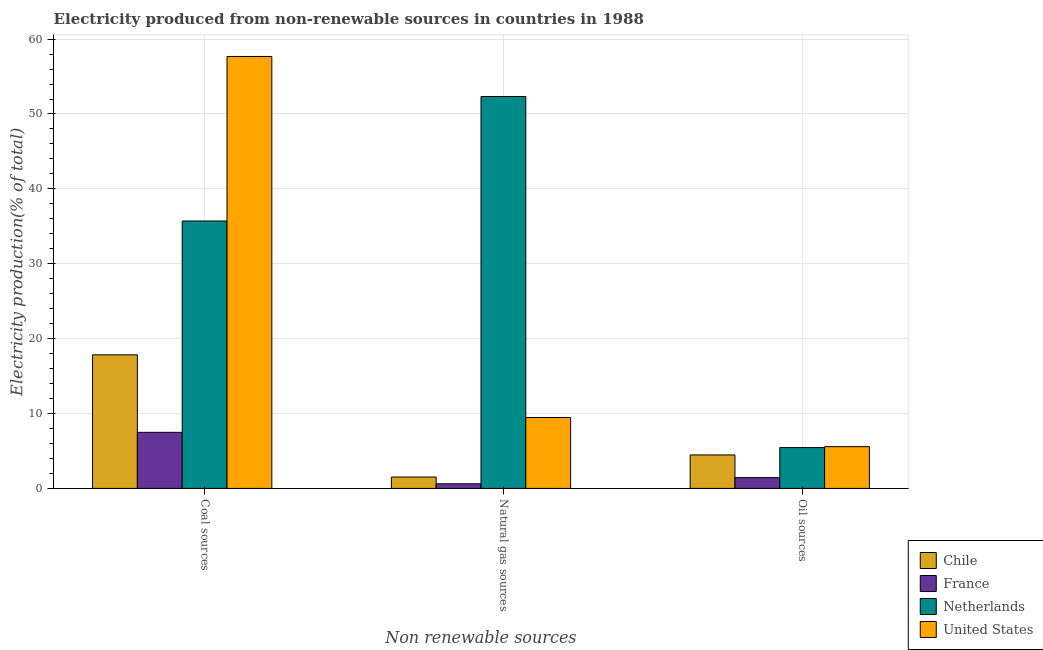How many groups of bars are there?
Provide a short and direct response. 3. Are the number of bars per tick equal to the number of legend labels?
Offer a very short reply. Yes. Are the number of bars on each tick of the X-axis equal?
Make the answer very short. Yes. How many bars are there on the 3rd tick from the left?
Offer a very short reply. 4. How many bars are there on the 3rd tick from the right?
Your answer should be compact. 4. What is the label of the 2nd group of bars from the left?
Give a very brief answer. Natural gas sources. What is the percentage of electricity produced by natural gas in United States?
Make the answer very short. 9.46. Across all countries, what is the maximum percentage of electricity produced by oil sources?
Provide a succinct answer. 5.57. Across all countries, what is the minimum percentage of electricity produced by oil sources?
Your response must be concise. 1.44. In which country was the percentage of electricity produced by coal minimum?
Offer a terse response. France. What is the total percentage of electricity produced by oil sources in the graph?
Your answer should be very brief. 16.94. What is the difference between the percentage of electricity produced by natural gas in Chile and that in United States?
Your answer should be compact. -7.95. What is the difference between the percentage of electricity produced by oil sources in United States and the percentage of electricity produced by coal in France?
Offer a terse response. -1.91. What is the average percentage of electricity produced by oil sources per country?
Your response must be concise. 4.23. What is the difference between the percentage of electricity produced by oil sources and percentage of electricity produced by coal in Netherlands?
Provide a succinct answer. -30.26. What is the ratio of the percentage of electricity produced by coal in France to that in Chile?
Your answer should be very brief. 0.42. Is the percentage of electricity produced by coal in Chile less than that in United States?
Give a very brief answer. Yes. Is the difference between the percentage of electricity produced by natural gas in Chile and Netherlands greater than the difference between the percentage of electricity produced by coal in Chile and Netherlands?
Give a very brief answer. No. What is the difference between the highest and the second highest percentage of electricity produced by oil sources?
Offer a very short reply. 0.12. What is the difference between the highest and the lowest percentage of electricity produced by oil sources?
Keep it short and to the point. 4.13. In how many countries, is the percentage of electricity produced by coal greater than the average percentage of electricity produced by coal taken over all countries?
Make the answer very short. 2. Is the sum of the percentage of electricity produced by oil sources in Netherlands and Chile greater than the maximum percentage of electricity produced by natural gas across all countries?
Make the answer very short. No. What does the 4th bar from the right in Oil sources represents?
Provide a succinct answer. Chile. Is it the case that in every country, the sum of the percentage of electricity produced by coal and percentage of electricity produced by natural gas is greater than the percentage of electricity produced by oil sources?
Offer a terse response. Yes. How many bars are there?
Offer a terse response. 12. What is the difference between two consecutive major ticks on the Y-axis?
Ensure brevity in your answer.  10. Does the graph contain grids?
Make the answer very short. Yes. Where does the legend appear in the graph?
Offer a terse response. Bottom right. How many legend labels are there?
Your answer should be very brief. 4. How are the legend labels stacked?
Provide a short and direct response. Vertical. What is the title of the graph?
Offer a terse response. Electricity produced from non-renewable sources in countries in 1988. What is the label or title of the X-axis?
Your answer should be compact. Non renewable sources. What is the Electricity production(% of total) of Chile in Coal sources?
Offer a terse response. 17.84. What is the Electricity production(% of total) in France in Coal sources?
Your answer should be compact. 7.49. What is the Electricity production(% of total) in Netherlands in Coal sources?
Offer a terse response. 35.71. What is the Electricity production(% of total) in United States in Coal sources?
Make the answer very short. 57.68. What is the Electricity production(% of total) in Chile in Natural gas sources?
Provide a succinct answer. 1.52. What is the Electricity production(% of total) of France in Natural gas sources?
Your response must be concise. 0.62. What is the Electricity production(% of total) in Netherlands in Natural gas sources?
Offer a very short reply. 52.33. What is the Electricity production(% of total) of United States in Natural gas sources?
Provide a succinct answer. 9.46. What is the Electricity production(% of total) of Chile in Oil sources?
Give a very brief answer. 4.47. What is the Electricity production(% of total) of France in Oil sources?
Provide a short and direct response. 1.44. What is the Electricity production(% of total) in Netherlands in Oil sources?
Keep it short and to the point. 5.45. What is the Electricity production(% of total) in United States in Oil sources?
Provide a short and direct response. 5.57. Across all Non renewable sources, what is the maximum Electricity production(% of total) of Chile?
Offer a terse response. 17.84. Across all Non renewable sources, what is the maximum Electricity production(% of total) of France?
Your answer should be compact. 7.49. Across all Non renewable sources, what is the maximum Electricity production(% of total) of Netherlands?
Provide a short and direct response. 52.33. Across all Non renewable sources, what is the maximum Electricity production(% of total) in United States?
Make the answer very short. 57.68. Across all Non renewable sources, what is the minimum Electricity production(% of total) in Chile?
Your response must be concise. 1.52. Across all Non renewable sources, what is the minimum Electricity production(% of total) of France?
Give a very brief answer. 0.62. Across all Non renewable sources, what is the minimum Electricity production(% of total) of Netherlands?
Keep it short and to the point. 5.45. Across all Non renewable sources, what is the minimum Electricity production(% of total) of United States?
Make the answer very short. 5.57. What is the total Electricity production(% of total) of Chile in the graph?
Ensure brevity in your answer.  23.82. What is the total Electricity production(% of total) in France in the graph?
Keep it short and to the point. 9.55. What is the total Electricity production(% of total) in Netherlands in the graph?
Keep it short and to the point. 93.5. What is the total Electricity production(% of total) in United States in the graph?
Provide a short and direct response. 72.72. What is the difference between the Electricity production(% of total) in Chile in Coal sources and that in Natural gas sources?
Make the answer very short. 16.32. What is the difference between the Electricity production(% of total) of France in Coal sources and that in Natural gas sources?
Make the answer very short. 6.87. What is the difference between the Electricity production(% of total) in Netherlands in Coal sources and that in Natural gas sources?
Ensure brevity in your answer.  -16.62. What is the difference between the Electricity production(% of total) of United States in Coal sources and that in Natural gas sources?
Make the answer very short. 48.21. What is the difference between the Electricity production(% of total) in Chile in Coal sources and that in Oil sources?
Keep it short and to the point. 13.37. What is the difference between the Electricity production(% of total) of France in Coal sources and that in Oil sources?
Provide a short and direct response. 6.05. What is the difference between the Electricity production(% of total) of Netherlands in Coal sources and that in Oil sources?
Offer a very short reply. 30.26. What is the difference between the Electricity production(% of total) of United States in Coal sources and that in Oil sources?
Make the answer very short. 52.1. What is the difference between the Electricity production(% of total) of Chile in Natural gas sources and that in Oil sources?
Your answer should be very brief. -2.95. What is the difference between the Electricity production(% of total) in France in Natural gas sources and that in Oil sources?
Provide a short and direct response. -0.82. What is the difference between the Electricity production(% of total) of Netherlands in Natural gas sources and that in Oil sources?
Make the answer very short. 46.88. What is the difference between the Electricity production(% of total) of United States in Natural gas sources and that in Oil sources?
Provide a succinct answer. 3.89. What is the difference between the Electricity production(% of total) in Chile in Coal sources and the Electricity production(% of total) in France in Natural gas sources?
Your response must be concise. 17.22. What is the difference between the Electricity production(% of total) of Chile in Coal sources and the Electricity production(% of total) of Netherlands in Natural gas sources?
Offer a very short reply. -34.49. What is the difference between the Electricity production(% of total) of Chile in Coal sources and the Electricity production(% of total) of United States in Natural gas sources?
Your answer should be very brief. 8.37. What is the difference between the Electricity production(% of total) in France in Coal sources and the Electricity production(% of total) in Netherlands in Natural gas sources?
Offer a very short reply. -44.84. What is the difference between the Electricity production(% of total) of France in Coal sources and the Electricity production(% of total) of United States in Natural gas sources?
Make the answer very short. -1.98. What is the difference between the Electricity production(% of total) in Netherlands in Coal sources and the Electricity production(% of total) in United States in Natural gas sources?
Make the answer very short. 26.25. What is the difference between the Electricity production(% of total) of Chile in Coal sources and the Electricity production(% of total) of France in Oil sources?
Offer a terse response. 16.39. What is the difference between the Electricity production(% of total) of Chile in Coal sources and the Electricity production(% of total) of Netherlands in Oil sources?
Offer a very short reply. 12.38. What is the difference between the Electricity production(% of total) of Chile in Coal sources and the Electricity production(% of total) of United States in Oil sources?
Your response must be concise. 12.26. What is the difference between the Electricity production(% of total) in France in Coal sources and the Electricity production(% of total) in Netherlands in Oil sources?
Give a very brief answer. 2.04. What is the difference between the Electricity production(% of total) of France in Coal sources and the Electricity production(% of total) of United States in Oil sources?
Provide a succinct answer. 1.91. What is the difference between the Electricity production(% of total) of Netherlands in Coal sources and the Electricity production(% of total) of United States in Oil sources?
Keep it short and to the point. 30.14. What is the difference between the Electricity production(% of total) of Chile in Natural gas sources and the Electricity production(% of total) of France in Oil sources?
Your answer should be very brief. 0.08. What is the difference between the Electricity production(% of total) of Chile in Natural gas sources and the Electricity production(% of total) of Netherlands in Oil sources?
Offer a terse response. -3.93. What is the difference between the Electricity production(% of total) in Chile in Natural gas sources and the Electricity production(% of total) in United States in Oil sources?
Your answer should be compact. -4.06. What is the difference between the Electricity production(% of total) in France in Natural gas sources and the Electricity production(% of total) in Netherlands in Oil sources?
Keep it short and to the point. -4.83. What is the difference between the Electricity production(% of total) in France in Natural gas sources and the Electricity production(% of total) in United States in Oil sources?
Your response must be concise. -4.96. What is the difference between the Electricity production(% of total) in Netherlands in Natural gas sources and the Electricity production(% of total) in United States in Oil sources?
Provide a short and direct response. 46.76. What is the average Electricity production(% of total) of Chile per Non renewable sources?
Your response must be concise. 7.94. What is the average Electricity production(% of total) of France per Non renewable sources?
Keep it short and to the point. 3.18. What is the average Electricity production(% of total) of Netherlands per Non renewable sources?
Give a very brief answer. 31.17. What is the average Electricity production(% of total) of United States per Non renewable sources?
Provide a short and direct response. 24.24. What is the difference between the Electricity production(% of total) of Chile and Electricity production(% of total) of France in Coal sources?
Provide a succinct answer. 10.35. What is the difference between the Electricity production(% of total) in Chile and Electricity production(% of total) in Netherlands in Coal sources?
Ensure brevity in your answer.  -17.88. What is the difference between the Electricity production(% of total) in Chile and Electricity production(% of total) in United States in Coal sources?
Make the answer very short. -39.84. What is the difference between the Electricity production(% of total) of France and Electricity production(% of total) of Netherlands in Coal sources?
Offer a very short reply. -28.22. What is the difference between the Electricity production(% of total) in France and Electricity production(% of total) in United States in Coal sources?
Provide a short and direct response. -50.19. What is the difference between the Electricity production(% of total) in Netherlands and Electricity production(% of total) in United States in Coal sources?
Give a very brief answer. -21.97. What is the difference between the Electricity production(% of total) in Chile and Electricity production(% of total) in France in Natural gas sources?
Ensure brevity in your answer.  0.9. What is the difference between the Electricity production(% of total) in Chile and Electricity production(% of total) in Netherlands in Natural gas sources?
Ensure brevity in your answer.  -50.81. What is the difference between the Electricity production(% of total) in Chile and Electricity production(% of total) in United States in Natural gas sources?
Provide a short and direct response. -7.95. What is the difference between the Electricity production(% of total) in France and Electricity production(% of total) in Netherlands in Natural gas sources?
Your answer should be compact. -51.71. What is the difference between the Electricity production(% of total) of France and Electricity production(% of total) of United States in Natural gas sources?
Provide a short and direct response. -8.85. What is the difference between the Electricity production(% of total) of Netherlands and Electricity production(% of total) of United States in Natural gas sources?
Make the answer very short. 42.87. What is the difference between the Electricity production(% of total) in Chile and Electricity production(% of total) in France in Oil sources?
Your answer should be compact. 3.03. What is the difference between the Electricity production(% of total) in Chile and Electricity production(% of total) in Netherlands in Oil sources?
Make the answer very short. -0.98. What is the difference between the Electricity production(% of total) in Chile and Electricity production(% of total) in United States in Oil sources?
Your response must be concise. -1.11. What is the difference between the Electricity production(% of total) of France and Electricity production(% of total) of Netherlands in Oil sources?
Offer a terse response. -4.01. What is the difference between the Electricity production(% of total) of France and Electricity production(% of total) of United States in Oil sources?
Make the answer very short. -4.13. What is the difference between the Electricity production(% of total) of Netherlands and Electricity production(% of total) of United States in Oil sources?
Ensure brevity in your answer.  -0.12. What is the ratio of the Electricity production(% of total) in Chile in Coal sources to that in Natural gas sources?
Offer a very short reply. 11.74. What is the ratio of the Electricity production(% of total) of France in Coal sources to that in Natural gas sources?
Provide a succinct answer. 12.11. What is the ratio of the Electricity production(% of total) of Netherlands in Coal sources to that in Natural gas sources?
Offer a terse response. 0.68. What is the ratio of the Electricity production(% of total) of United States in Coal sources to that in Natural gas sources?
Your answer should be very brief. 6.09. What is the ratio of the Electricity production(% of total) of Chile in Coal sources to that in Oil sources?
Keep it short and to the point. 3.99. What is the ratio of the Electricity production(% of total) of France in Coal sources to that in Oil sources?
Your response must be concise. 5.19. What is the ratio of the Electricity production(% of total) in Netherlands in Coal sources to that in Oil sources?
Your answer should be very brief. 6.55. What is the ratio of the Electricity production(% of total) in United States in Coal sources to that in Oil sources?
Provide a succinct answer. 10.35. What is the ratio of the Electricity production(% of total) in Chile in Natural gas sources to that in Oil sources?
Provide a succinct answer. 0.34. What is the ratio of the Electricity production(% of total) of France in Natural gas sources to that in Oil sources?
Offer a very short reply. 0.43. What is the ratio of the Electricity production(% of total) of Netherlands in Natural gas sources to that in Oil sources?
Provide a succinct answer. 9.6. What is the ratio of the Electricity production(% of total) in United States in Natural gas sources to that in Oil sources?
Offer a terse response. 1.7. What is the difference between the highest and the second highest Electricity production(% of total) of Chile?
Keep it short and to the point. 13.37. What is the difference between the highest and the second highest Electricity production(% of total) of France?
Keep it short and to the point. 6.05. What is the difference between the highest and the second highest Electricity production(% of total) in Netherlands?
Give a very brief answer. 16.62. What is the difference between the highest and the second highest Electricity production(% of total) in United States?
Provide a succinct answer. 48.21. What is the difference between the highest and the lowest Electricity production(% of total) in Chile?
Offer a very short reply. 16.32. What is the difference between the highest and the lowest Electricity production(% of total) of France?
Your response must be concise. 6.87. What is the difference between the highest and the lowest Electricity production(% of total) of Netherlands?
Make the answer very short. 46.88. What is the difference between the highest and the lowest Electricity production(% of total) in United States?
Give a very brief answer. 52.1. 